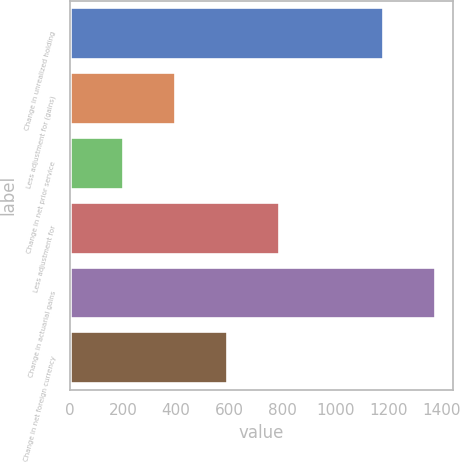<chart> <loc_0><loc_0><loc_500><loc_500><bar_chart><fcel>Change in unrealized holding<fcel>Less adjustment for (gains)<fcel>Change in net prior service<fcel>Less adjustment for<fcel>Change in actuarial gains<fcel>Change in net foreign currency<nl><fcel>1179.4<fcel>395.8<fcel>199.9<fcel>787.6<fcel>1375.3<fcel>591.7<nl></chart> 